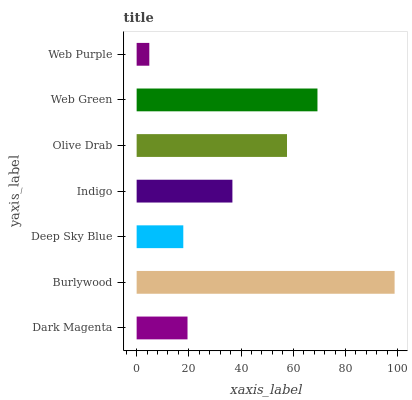Is Web Purple the minimum?
Answer yes or no. Yes. Is Burlywood the maximum?
Answer yes or no. Yes. Is Deep Sky Blue the minimum?
Answer yes or no. No. Is Deep Sky Blue the maximum?
Answer yes or no. No. Is Burlywood greater than Deep Sky Blue?
Answer yes or no. Yes. Is Deep Sky Blue less than Burlywood?
Answer yes or no. Yes. Is Deep Sky Blue greater than Burlywood?
Answer yes or no. No. Is Burlywood less than Deep Sky Blue?
Answer yes or no. No. Is Indigo the high median?
Answer yes or no. Yes. Is Indigo the low median?
Answer yes or no. Yes. Is Deep Sky Blue the high median?
Answer yes or no. No. Is Web Purple the low median?
Answer yes or no. No. 